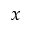Convert formula to latex. <formula><loc_0><loc_0><loc_500><loc_500>x</formula> 